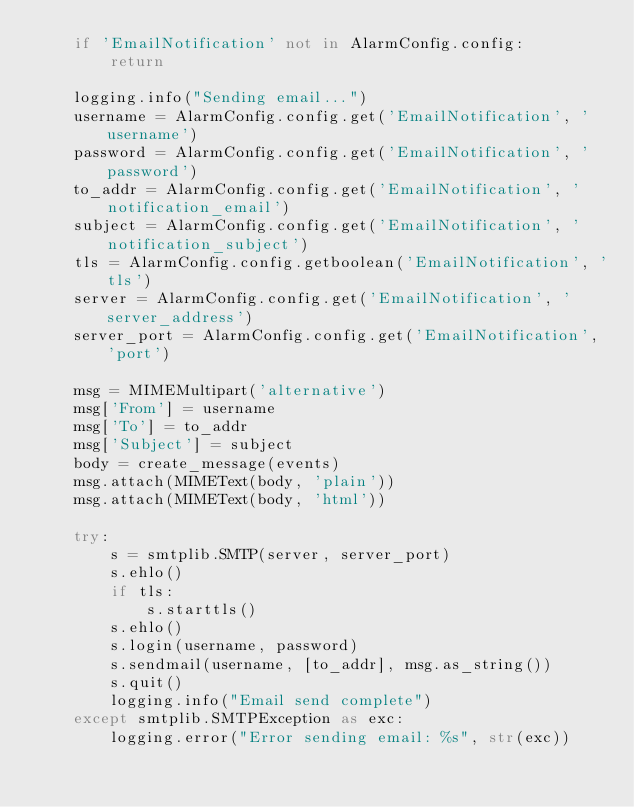Convert code to text. <code><loc_0><loc_0><loc_500><loc_500><_Python_>    if 'EmailNotification' not in AlarmConfig.config:
        return

    logging.info("Sending email...")
    username = AlarmConfig.config.get('EmailNotification', 'username')
    password = AlarmConfig.config.get('EmailNotification', 'password')
    to_addr = AlarmConfig.config.get('EmailNotification', 'notification_email')
    subject = AlarmConfig.config.get('EmailNotification', 'notification_subject')
    tls = AlarmConfig.config.getboolean('EmailNotification', 'tls')
    server = AlarmConfig.config.get('EmailNotification', 'server_address')
    server_port = AlarmConfig.config.get('EmailNotification', 'port')

    msg = MIMEMultipart('alternative')
    msg['From'] = username
    msg['To'] = to_addr
    msg['Subject'] = subject
    body = create_message(events)
    msg.attach(MIMEText(body, 'plain'))
    msg.attach(MIMEText(body, 'html'))

    try:
        s = smtplib.SMTP(server, server_port)
        s.ehlo()
        if tls:
            s.starttls()
        s.ehlo()
        s.login(username, password)
        s.sendmail(username, [to_addr], msg.as_string())
        s.quit()
        logging.info("Email send complete")
    except smtplib.SMTPException as exc:
        logging.error("Error sending email: %s", str(exc))
</code> 